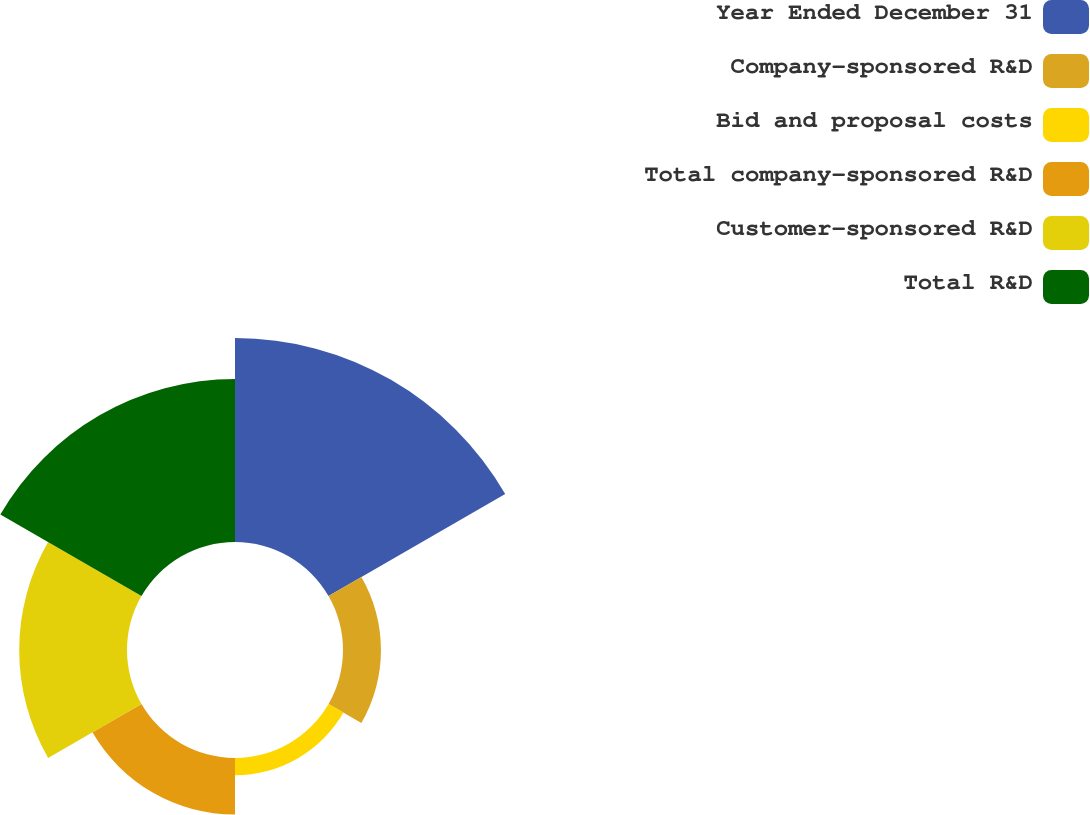Convert chart to OTSL. <chart><loc_0><loc_0><loc_500><loc_500><pie_chart><fcel>Year Ended December 31<fcel>Company-sponsored R&D<fcel>Bid and proposal costs<fcel>Total company-sponsored R&D<fcel>Customer-sponsored R&D<fcel>Total R&D<nl><fcel>34.78%<fcel>6.47%<fcel>2.94%<fcel>9.65%<fcel>18.38%<fcel>27.78%<nl></chart> 